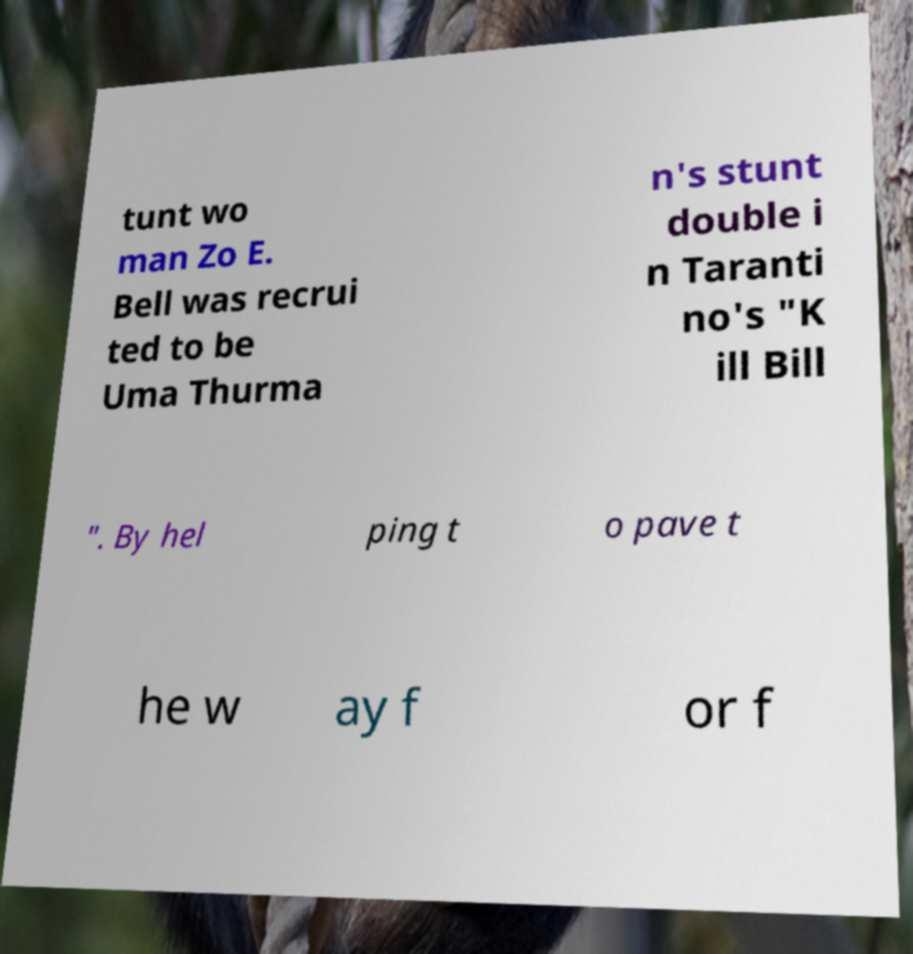There's text embedded in this image that I need extracted. Can you transcribe it verbatim? tunt wo man Zo E. Bell was recrui ted to be Uma Thurma n's stunt double i n Taranti no's "K ill Bill ". By hel ping t o pave t he w ay f or f 